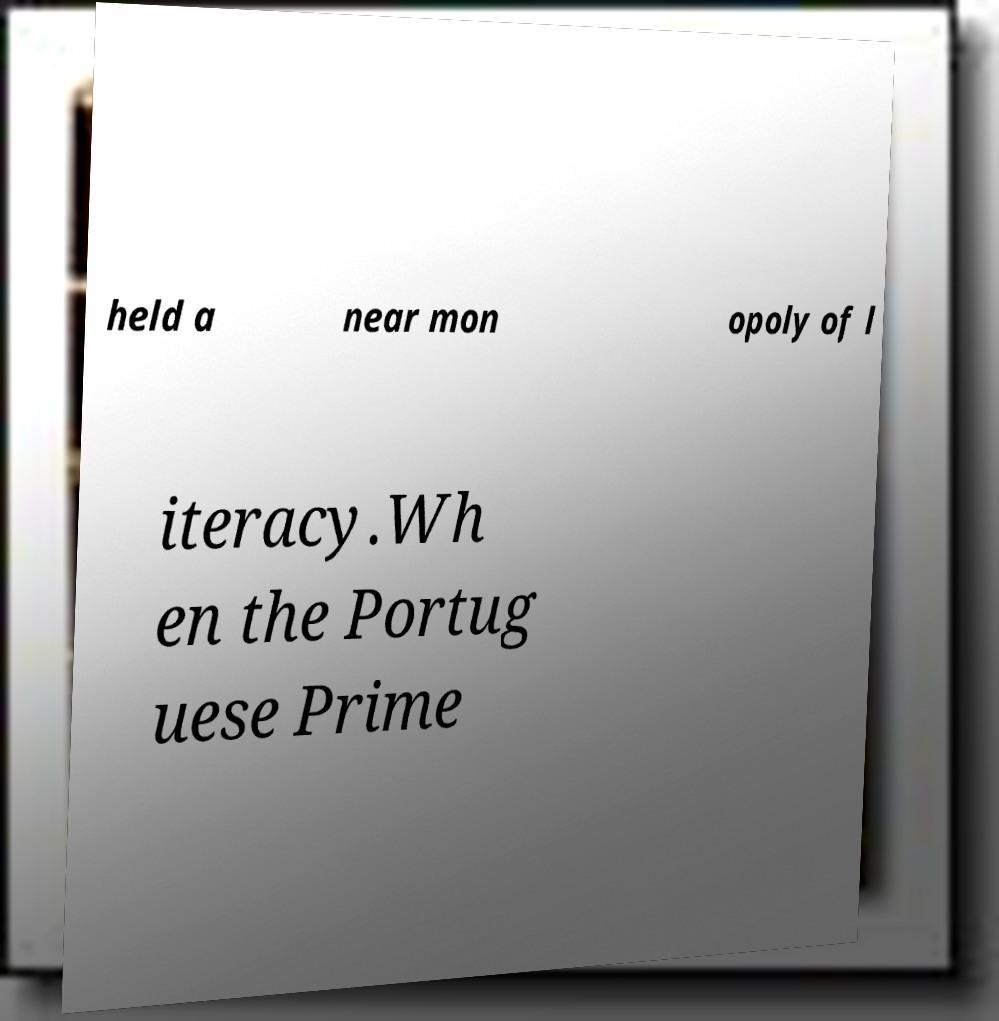I need the written content from this picture converted into text. Can you do that? held a near mon opoly of l iteracy.Wh en the Portug uese Prime 